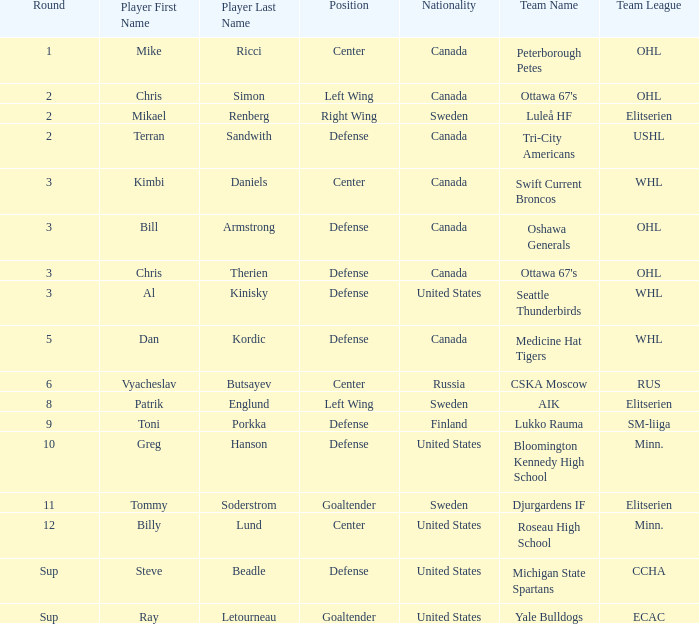Could you parse the entire table as a dict? {'header': ['Round', 'Player First Name', 'Player Last Name', 'Position', 'Nationality', 'Team Name', 'Team League'], 'rows': [['1', 'Mike', 'Ricci', 'Center', 'Canada', 'Peterborough Petes', 'OHL'], ['2', 'Chris', 'Simon', 'Left Wing', 'Canada', "Ottawa 67's", 'OHL'], ['2', 'Mikael', 'Renberg', 'Right Wing', 'Sweden', 'Luleå HF', 'Elitserien'], ['2', 'Terran', 'Sandwith', 'Defense', 'Canada', 'Tri-City Americans', 'USHL'], ['3', 'Kimbi', 'Daniels', 'Center', 'Canada', 'Swift Current Broncos', 'WHL'], ['3', 'Bill', 'Armstrong', 'Defense', 'Canada', 'Oshawa Generals', 'OHL'], ['3', 'Chris', 'Therien', 'Defense', 'Canada', "Ottawa 67's", 'OHL'], ['3', 'Al', 'Kinisky', 'Defense', 'United States', 'Seattle Thunderbirds', 'WHL'], ['5', 'Dan', 'Kordic', 'Defense', 'Canada', 'Medicine Hat Tigers', 'WHL'], ['6', 'Vyacheslav', 'Butsayev', 'Center', 'Russia', 'CSKA Moscow', 'RUS'], ['8', 'Patrik', 'Englund', 'Left Wing', 'Sweden', 'AIK', 'Elitserien'], ['9', 'Toni', 'Porkka', 'Defense', 'Finland', 'Lukko Rauma', 'SM-liiga'], ['10', 'Greg', 'Hanson', 'Defense', 'United States', 'Bloomington Kennedy High School', 'Minn.'], ['11', 'Tommy', 'Soderstrom', 'Goaltender', 'Sweden', 'Djurgardens IF', 'Elitserien'], ['12', 'Billy', 'Lund', 'Center', 'United States', 'Roseau High School', 'Minn.'], ['Sup', 'Steve', 'Beadle', 'Defense', 'United States', 'Michigan State Spartans', 'CCHA'], ['Sup', 'Ray', 'Letourneau', 'Goaltender', 'United States', 'Yale Bulldogs', 'ECAC']]} What is the school that hosts mikael renberg Luleå HF ( Elitserien ). 